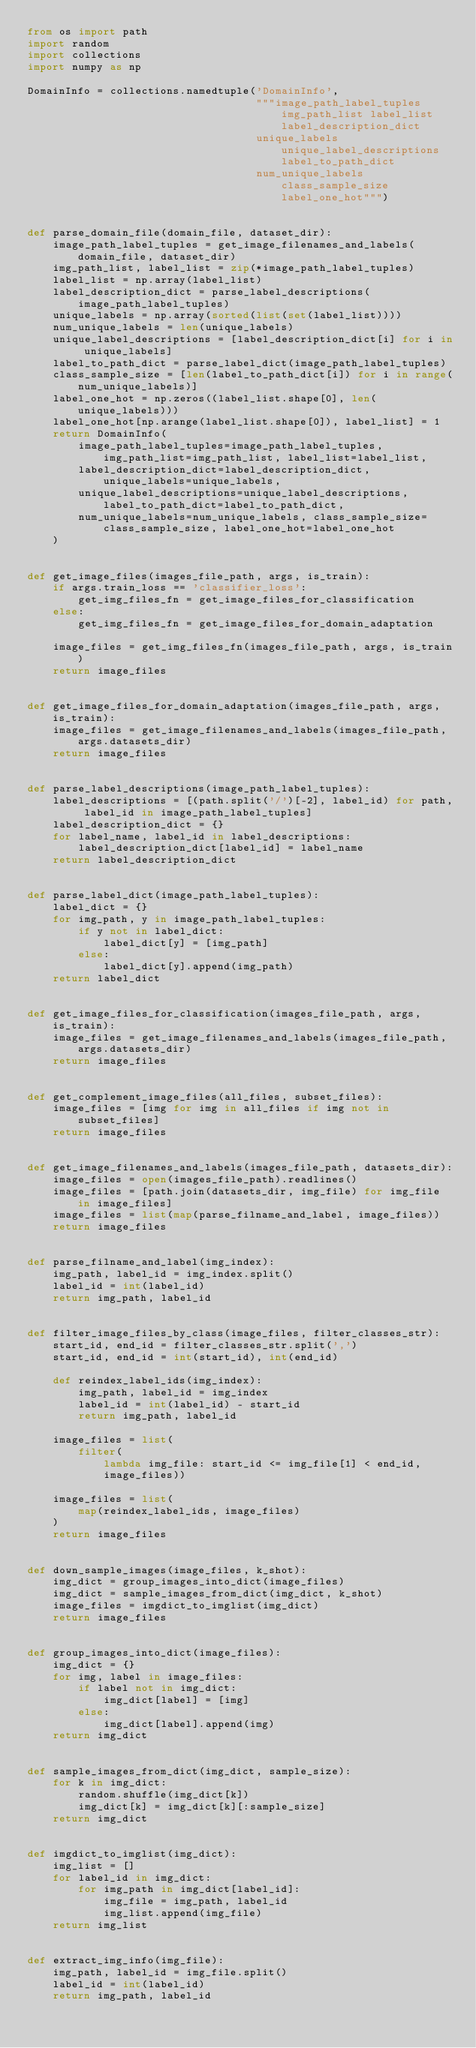Convert code to text. <code><loc_0><loc_0><loc_500><loc_500><_Python_>from os import path
import random
import collections
import numpy as np

DomainInfo = collections.namedtuple('DomainInfo',
                                    """image_path_label_tuples img_path_list label_list label_description_dict 
                                    unique_labels unique_label_descriptions label_to_path_dict 
                                    num_unique_labels class_sample_size label_one_hot""")


def parse_domain_file(domain_file, dataset_dir):
    image_path_label_tuples = get_image_filenames_and_labels(domain_file, dataset_dir)
    img_path_list, label_list = zip(*image_path_label_tuples)
    label_list = np.array(label_list)
    label_description_dict = parse_label_descriptions(image_path_label_tuples)
    unique_labels = np.array(sorted(list(set(label_list))))
    num_unique_labels = len(unique_labels)
    unique_label_descriptions = [label_description_dict[i] for i in unique_labels]
    label_to_path_dict = parse_label_dict(image_path_label_tuples)
    class_sample_size = [len(label_to_path_dict[i]) for i in range(num_unique_labels)]
    label_one_hot = np.zeros((label_list.shape[0], len(unique_labels)))
    label_one_hot[np.arange(label_list.shape[0]), label_list] = 1
    return DomainInfo(
        image_path_label_tuples=image_path_label_tuples, img_path_list=img_path_list, label_list=label_list,
        label_description_dict=label_description_dict, unique_labels=unique_labels,
        unique_label_descriptions=unique_label_descriptions, label_to_path_dict=label_to_path_dict,
        num_unique_labels=num_unique_labels, class_sample_size=class_sample_size, label_one_hot=label_one_hot
    )


def get_image_files(images_file_path, args, is_train):
    if args.train_loss == 'classifier_loss':
        get_img_files_fn = get_image_files_for_classification
    else:
        get_img_files_fn = get_image_files_for_domain_adaptation

    image_files = get_img_files_fn(images_file_path, args, is_train)
    return image_files


def get_image_files_for_domain_adaptation(images_file_path, args, is_train):
    image_files = get_image_filenames_and_labels(images_file_path, args.datasets_dir)
    return image_files


def parse_label_descriptions(image_path_label_tuples):
    label_descriptions = [(path.split('/')[-2], label_id) for path, label_id in image_path_label_tuples]
    label_description_dict = {}
    for label_name, label_id in label_descriptions:
        label_description_dict[label_id] = label_name
    return label_description_dict


def parse_label_dict(image_path_label_tuples):
    label_dict = {}
    for img_path, y in image_path_label_tuples:
        if y not in label_dict:
            label_dict[y] = [img_path]
        else:
            label_dict[y].append(img_path)
    return label_dict


def get_image_files_for_classification(images_file_path, args, is_train):
    image_files = get_image_filenames_and_labels(images_file_path, args.datasets_dir)
    return image_files


def get_complement_image_files(all_files, subset_files):
    image_files = [img for img in all_files if img not in subset_files]
    return image_files


def get_image_filenames_and_labels(images_file_path, datasets_dir):
    image_files = open(images_file_path).readlines()
    image_files = [path.join(datasets_dir, img_file) for img_file in image_files]
    image_files = list(map(parse_filname_and_label, image_files))
    return image_files


def parse_filname_and_label(img_index):
    img_path, label_id = img_index.split()
    label_id = int(label_id)
    return img_path, label_id


def filter_image_files_by_class(image_files, filter_classes_str):
    start_id, end_id = filter_classes_str.split(',')
    start_id, end_id = int(start_id), int(end_id)

    def reindex_label_ids(img_index):
        img_path, label_id = img_index
        label_id = int(label_id) - start_id
        return img_path, label_id

    image_files = list(
        filter(
            lambda img_file: start_id <= img_file[1] < end_id,
            image_files))

    image_files = list(
        map(reindex_label_ids, image_files)
    )
    return image_files


def down_sample_images(image_files, k_shot):
    img_dict = group_images_into_dict(image_files)
    img_dict = sample_images_from_dict(img_dict, k_shot)
    image_files = imgdict_to_imglist(img_dict)
    return image_files


def group_images_into_dict(image_files):
    img_dict = {}
    for img, label in image_files:
        if label not in img_dict:
            img_dict[label] = [img]
        else:
            img_dict[label].append(img)
    return img_dict


def sample_images_from_dict(img_dict, sample_size):
    for k in img_dict:
        random.shuffle(img_dict[k])
        img_dict[k] = img_dict[k][:sample_size]
    return img_dict


def imgdict_to_imglist(img_dict):
    img_list = []
    for label_id in img_dict:
        for img_path in img_dict[label_id]:
            img_file = img_path, label_id
            img_list.append(img_file)
    return img_list


def extract_img_info(img_file):
    img_path, label_id = img_file.split()
    label_id = int(label_id)
    return img_path, label_id
</code> 